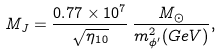Convert formula to latex. <formula><loc_0><loc_0><loc_500><loc_500>M _ { J } = \frac { 0 . 7 7 \times 1 0 ^ { 7 } } { \sqrt { \eta _ { 1 0 } } } \, \frac { M _ { \odot } } { m _ { \phi ^ { \prime } } ^ { 2 } ( G e V ) } ,</formula> 